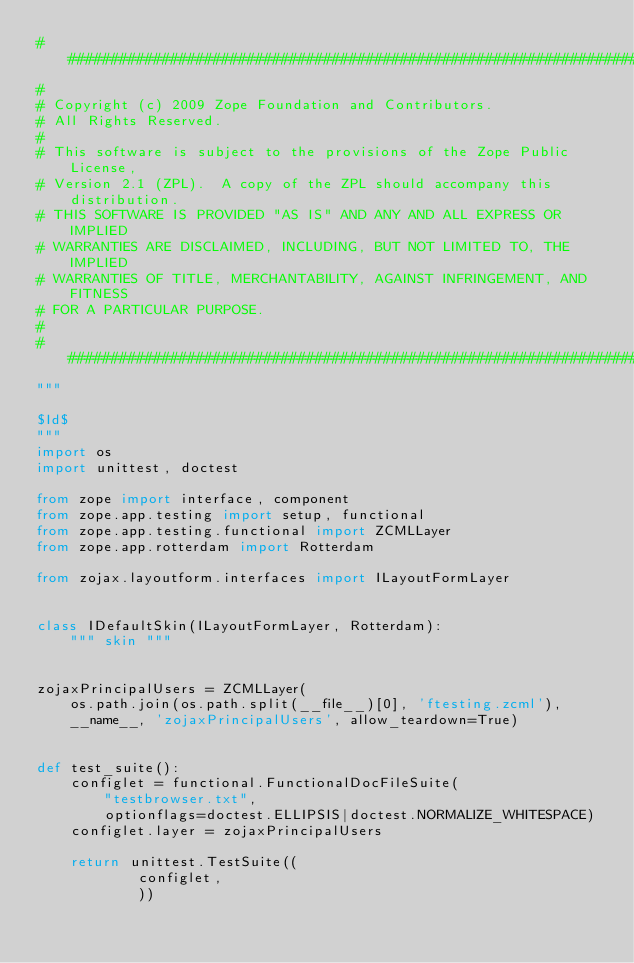Convert code to text. <code><loc_0><loc_0><loc_500><loc_500><_Python_>##############################################################################
#
# Copyright (c) 2009 Zope Foundation and Contributors.
# All Rights Reserved.
#
# This software is subject to the provisions of the Zope Public License,
# Version 2.1 (ZPL).  A copy of the ZPL should accompany this distribution.
# THIS SOFTWARE IS PROVIDED "AS IS" AND ANY AND ALL EXPRESS OR IMPLIED
# WARRANTIES ARE DISCLAIMED, INCLUDING, BUT NOT LIMITED TO, THE IMPLIED
# WARRANTIES OF TITLE, MERCHANTABILITY, AGAINST INFRINGEMENT, AND FITNESS
# FOR A PARTICULAR PURPOSE.
#
##############################################################################
"""

$Id$
"""
import os
import unittest, doctest

from zope import interface, component
from zope.app.testing import setup, functional
from zope.app.testing.functional import ZCMLLayer
from zope.app.rotterdam import Rotterdam

from zojax.layoutform.interfaces import ILayoutFormLayer


class IDefaultSkin(ILayoutFormLayer, Rotterdam):
    """ skin """


zojaxPrincipalUsers = ZCMLLayer(
    os.path.join(os.path.split(__file__)[0], 'ftesting.zcml'),
    __name__, 'zojaxPrincipalUsers', allow_teardown=True)


def test_suite():
    configlet = functional.FunctionalDocFileSuite(
        "testbrowser.txt",
        optionflags=doctest.ELLIPSIS|doctest.NORMALIZE_WHITESPACE)
    configlet.layer = zojaxPrincipalUsers

    return unittest.TestSuite((
            configlet,
            ))
</code> 